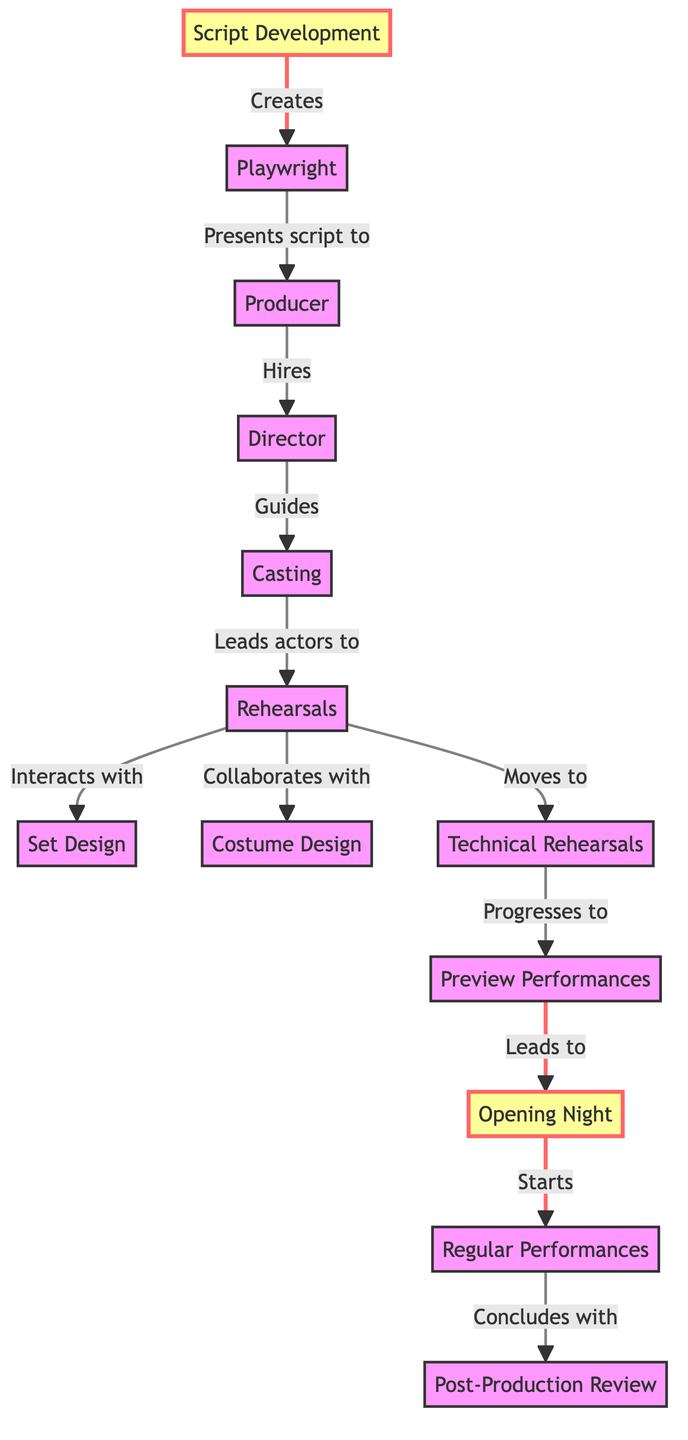What is the first step in the lifecycle of theatrical productions? The diagram indicates that the first step is "Script Development," which is reflected as the starting node in the flowchart.
Answer: Script Development Who presents the script to the producer? According to the flowchart, the playwright is responsible for presenting the script to the producer, as indicated by the arrow connecting these two nodes.
Answer: Playwright What role does the director have in relation to casting? The flowchart shows that the director guides the casting process while interacting with the casting node, establishing a direct relationship between them.
Answer: Guides How many main roles are depicted in the flowchart? The diagram showcases five main roles: Playwright, Producer, Director, Casting, and Actors, making a total of five nodes that represent roles.
Answer: Five What follows after technical rehearsals in the lifecycle? The flowchart illustrates that technical rehearsals progress to preview performances, which is the next step in the sequence.
Answer: Preview Performances Which step comes directly before opening night? Based on the diagram, the step that comes directly before opening night is the preview performances, as per the connections in the flowchart.
Answer: Preview Performances What is the final step indicated in the lifecycle of theatrical productions? The flowchart concludes with the post-production review as the final step in the sequence, representing the end of the lifecycle.
Answer: Post-Production Review Which two steps involve collaboration? The diagram specifies that rehearsals involve collaboration with both set design and costume design, indicating the connections amongst these nodes.
Answer: Rehearsals and Set Design, Costume Design How do regular performances relate to opening night? The flowchart shows that regular performances start after opening night, establishing a sequential relationship between these two steps.
Answer: Start after Opening Night 